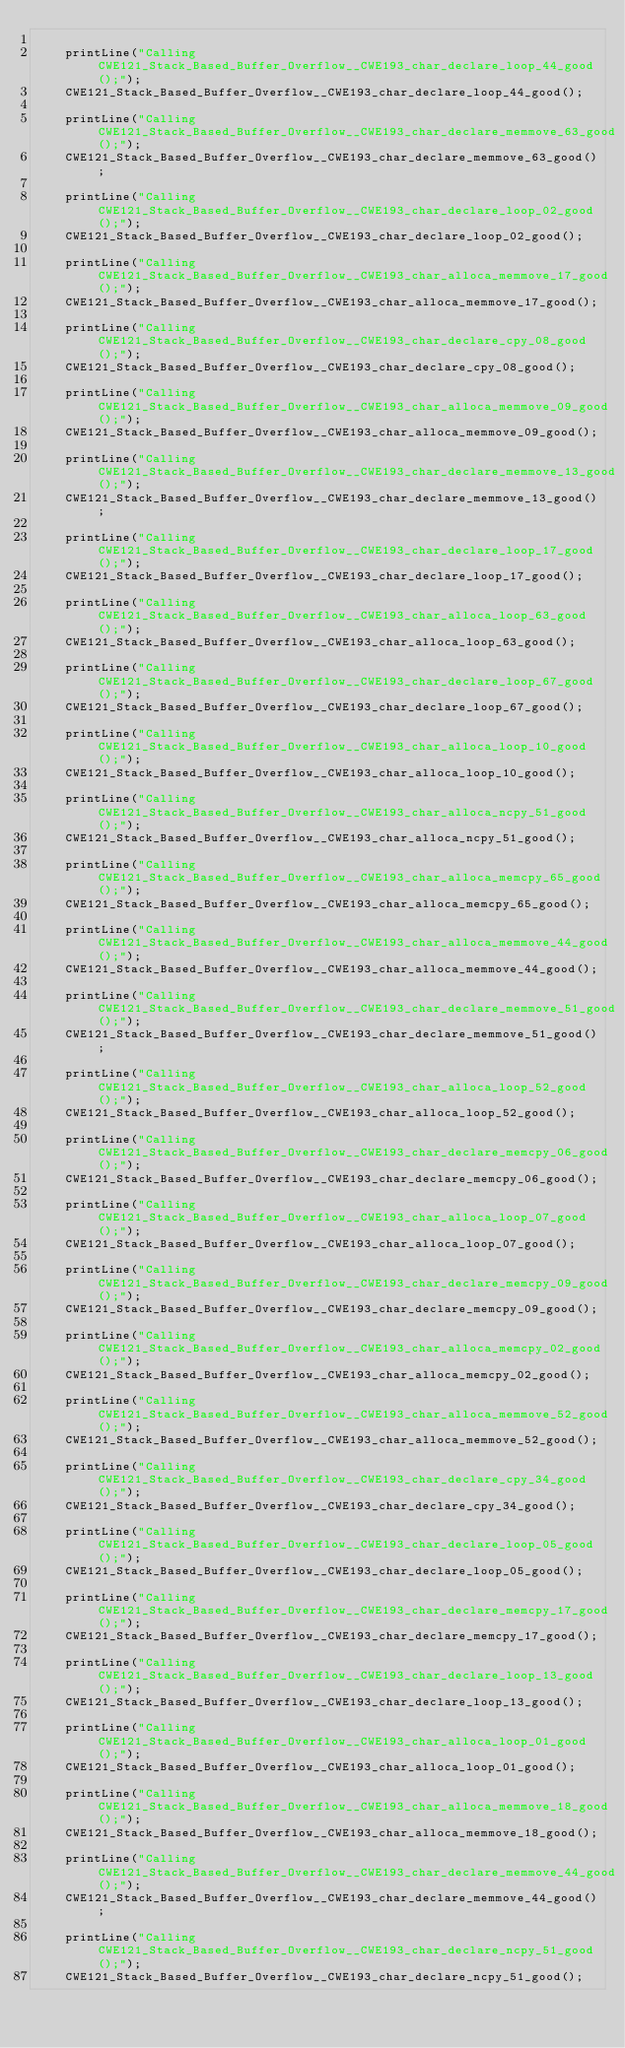<code> <loc_0><loc_0><loc_500><loc_500><_C++_>
	printLine("Calling CWE121_Stack_Based_Buffer_Overflow__CWE193_char_declare_loop_44_good();");
	CWE121_Stack_Based_Buffer_Overflow__CWE193_char_declare_loop_44_good();

	printLine("Calling CWE121_Stack_Based_Buffer_Overflow__CWE193_char_declare_memmove_63_good();");
	CWE121_Stack_Based_Buffer_Overflow__CWE193_char_declare_memmove_63_good();

	printLine("Calling CWE121_Stack_Based_Buffer_Overflow__CWE193_char_declare_loop_02_good();");
	CWE121_Stack_Based_Buffer_Overflow__CWE193_char_declare_loop_02_good();

	printLine("Calling CWE121_Stack_Based_Buffer_Overflow__CWE193_char_alloca_memmove_17_good();");
	CWE121_Stack_Based_Buffer_Overflow__CWE193_char_alloca_memmove_17_good();

	printLine("Calling CWE121_Stack_Based_Buffer_Overflow__CWE193_char_declare_cpy_08_good();");
	CWE121_Stack_Based_Buffer_Overflow__CWE193_char_declare_cpy_08_good();

	printLine("Calling CWE121_Stack_Based_Buffer_Overflow__CWE193_char_alloca_memmove_09_good();");
	CWE121_Stack_Based_Buffer_Overflow__CWE193_char_alloca_memmove_09_good();

	printLine("Calling CWE121_Stack_Based_Buffer_Overflow__CWE193_char_declare_memmove_13_good();");
	CWE121_Stack_Based_Buffer_Overflow__CWE193_char_declare_memmove_13_good();

	printLine("Calling CWE121_Stack_Based_Buffer_Overflow__CWE193_char_declare_loop_17_good();");
	CWE121_Stack_Based_Buffer_Overflow__CWE193_char_declare_loop_17_good();

	printLine("Calling CWE121_Stack_Based_Buffer_Overflow__CWE193_char_alloca_loop_63_good();");
	CWE121_Stack_Based_Buffer_Overflow__CWE193_char_alloca_loop_63_good();

	printLine("Calling CWE121_Stack_Based_Buffer_Overflow__CWE193_char_declare_loop_67_good();");
	CWE121_Stack_Based_Buffer_Overflow__CWE193_char_declare_loop_67_good();

	printLine("Calling CWE121_Stack_Based_Buffer_Overflow__CWE193_char_alloca_loop_10_good();");
	CWE121_Stack_Based_Buffer_Overflow__CWE193_char_alloca_loop_10_good();

	printLine("Calling CWE121_Stack_Based_Buffer_Overflow__CWE193_char_alloca_ncpy_51_good();");
	CWE121_Stack_Based_Buffer_Overflow__CWE193_char_alloca_ncpy_51_good();

	printLine("Calling CWE121_Stack_Based_Buffer_Overflow__CWE193_char_alloca_memcpy_65_good();");
	CWE121_Stack_Based_Buffer_Overflow__CWE193_char_alloca_memcpy_65_good();

	printLine("Calling CWE121_Stack_Based_Buffer_Overflow__CWE193_char_alloca_memmove_44_good();");
	CWE121_Stack_Based_Buffer_Overflow__CWE193_char_alloca_memmove_44_good();

	printLine("Calling CWE121_Stack_Based_Buffer_Overflow__CWE193_char_declare_memmove_51_good();");
	CWE121_Stack_Based_Buffer_Overflow__CWE193_char_declare_memmove_51_good();

	printLine("Calling CWE121_Stack_Based_Buffer_Overflow__CWE193_char_alloca_loop_52_good();");
	CWE121_Stack_Based_Buffer_Overflow__CWE193_char_alloca_loop_52_good();

	printLine("Calling CWE121_Stack_Based_Buffer_Overflow__CWE193_char_declare_memcpy_06_good();");
	CWE121_Stack_Based_Buffer_Overflow__CWE193_char_declare_memcpy_06_good();

	printLine("Calling CWE121_Stack_Based_Buffer_Overflow__CWE193_char_alloca_loop_07_good();");
	CWE121_Stack_Based_Buffer_Overflow__CWE193_char_alloca_loop_07_good();

	printLine("Calling CWE121_Stack_Based_Buffer_Overflow__CWE193_char_declare_memcpy_09_good();");
	CWE121_Stack_Based_Buffer_Overflow__CWE193_char_declare_memcpy_09_good();

	printLine("Calling CWE121_Stack_Based_Buffer_Overflow__CWE193_char_alloca_memcpy_02_good();");
	CWE121_Stack_Based_Buffer_Overflow__CWE193_char_alloca_memcpy_02_good();

	printLine("Calling CWE121_Stack_Based_Buffer_Overflow__CWE193_char_alloca_memmove_52_good();");
	CWE121_Stack_Based_Buffer_Overflow__CWE193_char_alloca_memmove_52_good();

	printLine("Calling CWE121_Stack_Based_Buffer_Overflow__CWE193_char_declare_cpy_34_good();");
	CWE121_Stack_Based_Buffer_Overflow__CWE193_char_declare_cpy_34_good();

	printLine("Calling CWE121_Stack_Based_Buffer_Overflow__CWE193_char_declare_loop_05_good();");
	CWE121_Stack_Based_Buffer_Overflow__CWE193_char_declare_loop_05_good();

	printLine("Calling CWE121_Stack_Based_Buffer_Overflow__CWE193_char_declare_memcpy_17_good();");
	CWE121_Stack_Based_Buffer_Overflow__CWE193_char_declare_memcpy_17_good();

	printLine("Calling CWE121_Stack_Based_Buffer_Overflow__CWE193_char_declare_loop_13_good();");
	CWE121_Stack_Based_Buffer_Overflow__CWE193_char_declare_loop_13_good();

	printLine("Calling CWE121_Stack_Based_Buffer_Overflow__CWE193_char_alloca_loop_01_good();");
	CWE121_Stack_Based_Buffer_Overflow__CWE193_char_alloca_loop_01_good();

	printLine("Calling CWE121_Stack_Based_Buffer_Overflow__CWE193_char_alloca_memmove_18_good();");
	CWE121_Stack_Based_Buffer_Overflow__CWE193_char_alloca_memmove_18_good();

	printLine("Calling CWE121_Stack_Based_Buffer_Overflow__CWE193_char_declare_memmove_44_good();");
	CWE121_Stack_Based_Buffer_Overflow__CWE193_char_declare_memmove_44_good();

	printLine("Calling CWE121_Stack_Based_Buffer_Overflow__CWE193_char_declare_ncpy_51_good();");
	CWE121_Stack_Based_Buffer_Overflow__CWE193_char_declare_ncpy_51_good();
</code> 